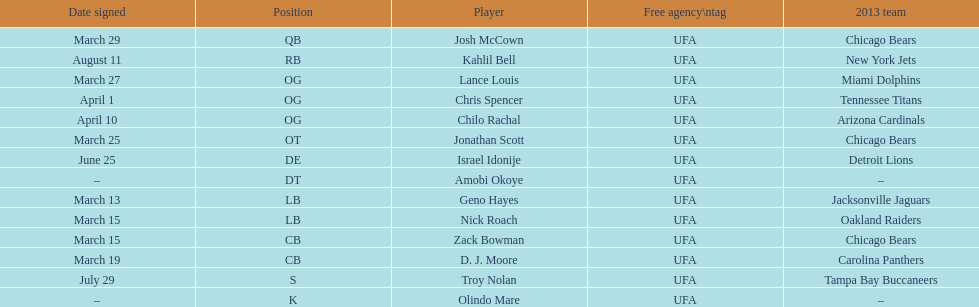Who was the previous player signed before troy nolan? Israel Idonije. 